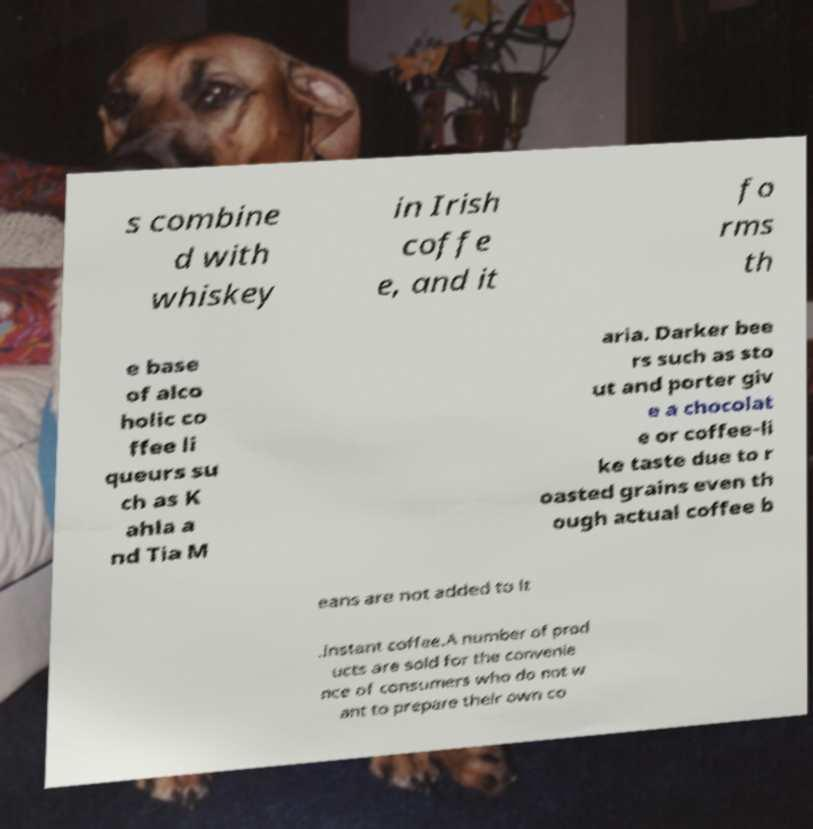Can you read and provide the text displayed in the image?This photo seems to have some interesting text. Can you extract and type it out for me? s combine d with whiskey in Irish coffe e, and it fo rms th e base of alco holic co ffee li queurs su ch as K ahla a nd Tia M aria. Darker bee rs such as sto ut and porter giv e a chocolat e or coffee-li ke taste due to r oasted grains even th ough actual coffee b eans are not added to it .Instant coffee.A number of prod ucts are sold for the convenie nce of consumers who do not w ant to prepare their own co 